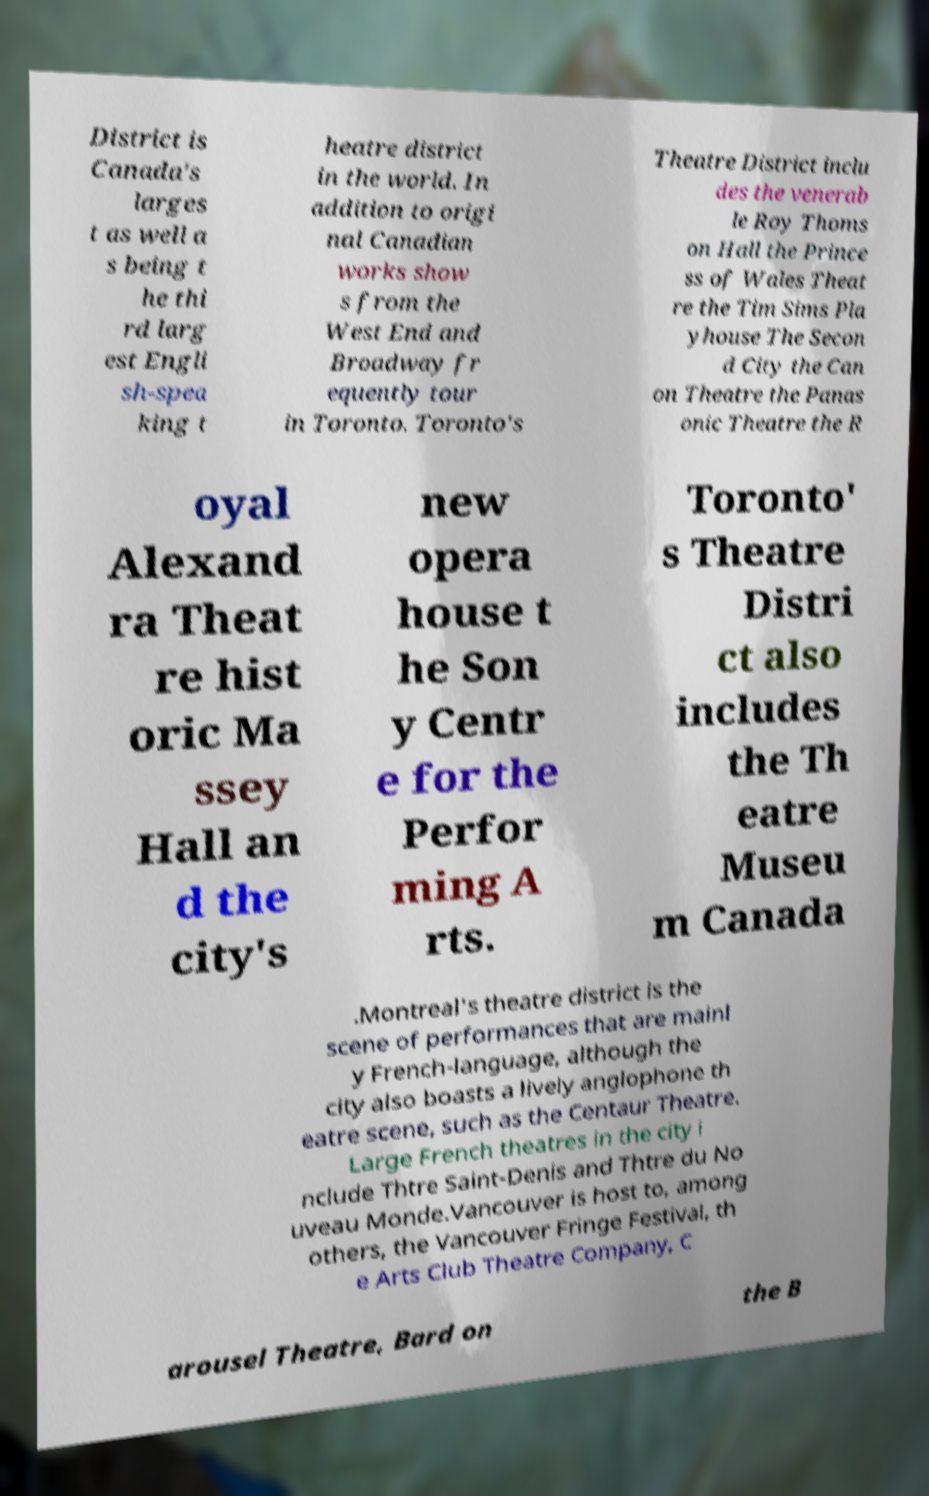What messages or text are displayed in this image? I need them in a readable, typed format. District is Canada's larges t as well a s being t he thi rd larg est Engli sh-spea king t heatre district in the world. In addition to origi nal Canadian works show s from the West End and Broadway fr equently tour in Toronto. Toronto's Theatre District inclu des the venerab le Roy Thoms on Hall the Prince ss of Wales Theat re the Tim Sims Pla yhouse The Secon d City the Can on Theatre the Panas onic Theatre the R oyal Alexand ra Theat re hist oric Ma ssey Hall an d the city's new opera house t he Son y Centr e for the Perfor ming A rts. Toronto' s Theatre Distri ct also includes the Th eatre Museu m Canada .Montreal's theatre district is the scene of performances that are mainl y French-language, although the city also boasts a lively anglophone th eatre scene, such as the Centaur Theatre. Large French theatres in the city i nclude Thtre Saint-Denis and Thtre du No uveau Monde.Vancouver is host to, among others, the Vancouver Fringe Festival, th e Arts Club Theatre Company, C arousel Theatre, Bard on the B 